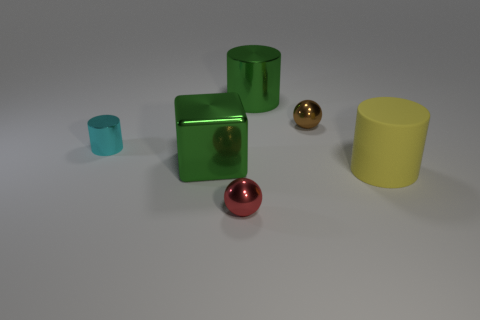The shiny thing that is the same color as the big cube is what size? The shiny object sharing the color with the larger cube appears to be a small sphere, noticeably smaller in size compared to the cubic object. 